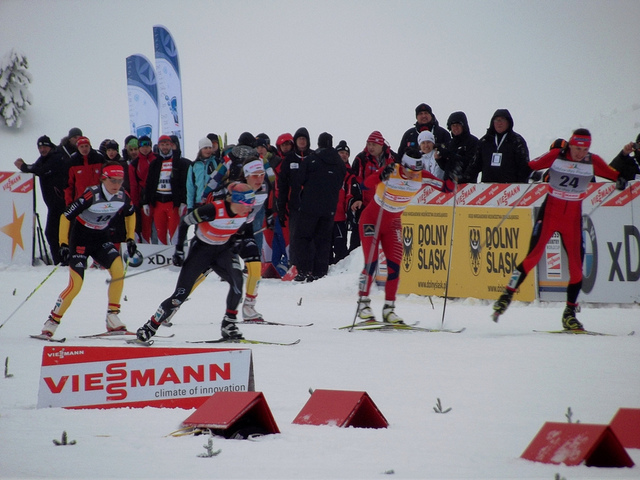What do the varying ski suits and styles tell us? The different colors and designs on the ski suits indicate diversity in team affiliations or nationalities, reflecting the individual identities and sponsorships of the competitors. 